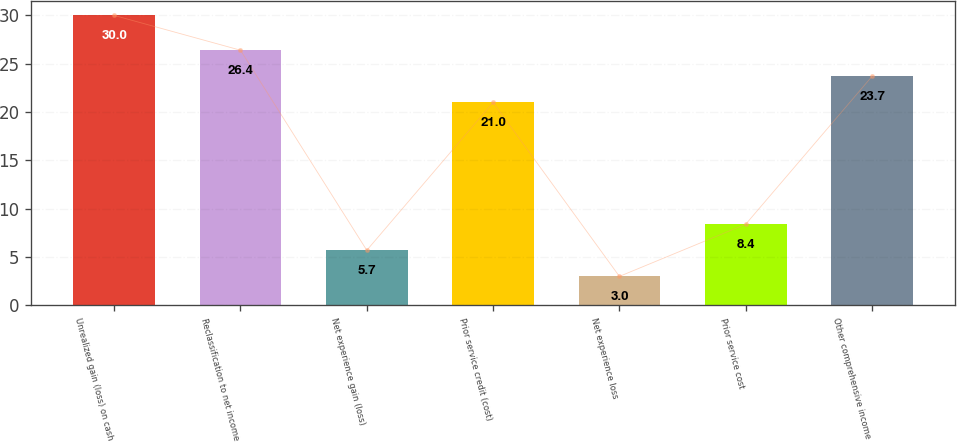<chart> <loc_0><loc_0><loc_500><loc_500><bar_chart><fcel>Unrealized gain (loss) on cash<fcel>Reclassification to net income<fcel>Net experience gain (loss)<fcel>Prior service credit (cost)<fcel>Net experience loss<fcel>Prior service cost<fcel>Other comprehensive income<nl><fcel>30<fcel>26.4<fcel>5.7<fcel>21<fcel>3<fcel>8.4<fcel>23.7<nl></chart> 